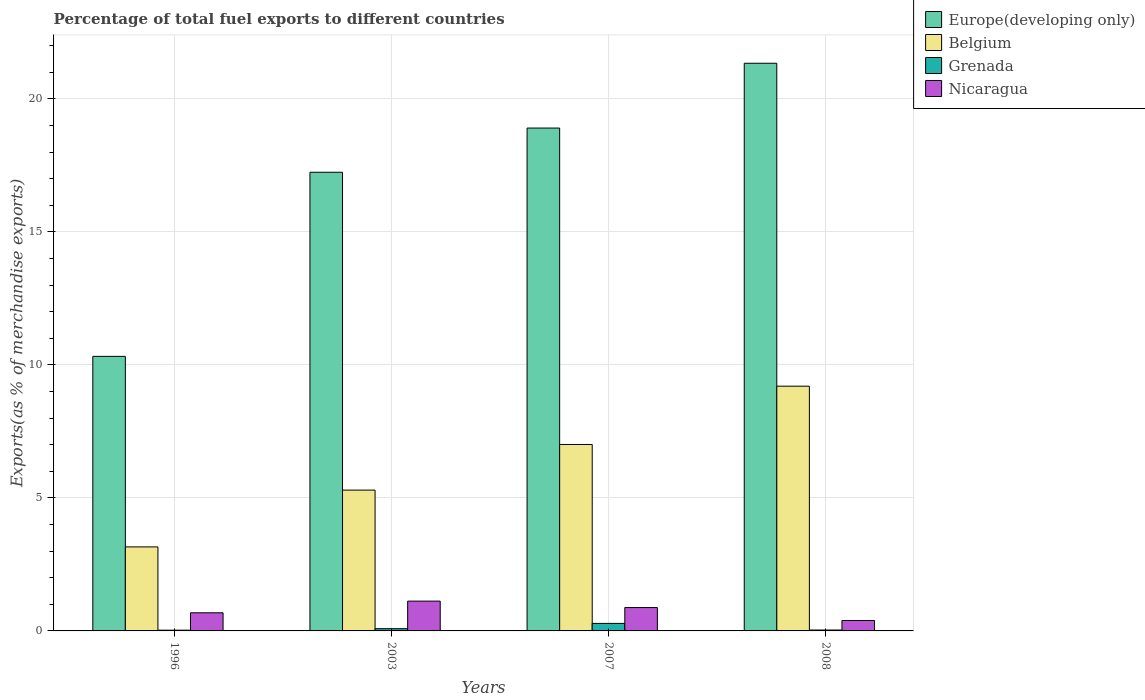Are the number of bars on each tick of the X-axis equal?
Make the answer very short. Yes. How many bars are there on the 1st tick from the right?
Your answer should be compact. 4. In how many cases, is the number of bars for a given year not equal to the number of legend labels?
Make the answer very short. 0. What is the percentage of exports to different countries in Europe(developing only) in 2008?
Your response must be concise. 21.34. Across all years, what is the maximum percentage of exports to different countries in Belgium?
Ensure brevity in your answer.  9.2. Across all years, what is the minimum percentage of exports to different countries in Belgium?
Offer a very short reply. 3.16. What is the total percentage of exports to different countries in Belgium in the graph?
Provide a succinct answer. 24.66. What is the difference between the percentage of exports to different countries in Grenada in 2007 and that in 2008?
Make the answer very short. 0.25. What is the difference between the percentage of exports to different countries in Grenada in 2007 and the percentage of exports to different countries in Nicaragua in 1996?
Give a very brief answer. -0.4. What is the average percentage of exports to different countries in Nicaragua per year?
Offer a very short reply. 0.77. In the year 2003, what is the difference between the percentage of exports to different countries in Belgium and percentage of exports to different countries in Grenada?
Offer a very short reply. 5.21. In how many years, is the percentage of exports to different countries in Europe(developing only) greater than 15 %?
Give a very brief answer. 3. What is the ratio of the percentage of exports to different countries in Europe(developing only) in 1996 to that in 2008?
Ensure brevity in your answer.  0.48. Is the percentage of exports to different countries in Nicaragua in 1996 less than that in 2008?
Ensure brevity in your answer.  No. Is the difference between the percentage of exports to different countries in Belgium in 1996 and 2008 greater than the difference between the percentage of exports to different countries in Grenada in 1996 and 2008?
Ensure brevity in your answer.  No. What is the difference between the highest and the second highest percentage of exports to different countries in Europe(developing only)?
Provide a short and direct response. 2.44. What is the difference between the highest and the lowest percentage of exports to different countries in Grenada?
Ensure brevity in your answer.  0.25. In how many years, is the percentage of exports to different countries in Europe(developing only) greater than the average percentage of exports to different countries in Europe(developing only) taken over all years?
Provide a succinct answer. 3. Is the sum of the percentage of exports to different countries in Belgium in 2003 and 2008 greater than the maximum percentage of exports to different countries in Nicaragua across all years?
Provide a succinct answer. Yes. Is it the case that in every year, the sum of the percentage of exports to different countries in Grenada and percentage of exports to different countries in Nicaragua is greater than the sum of percentage of exports to different countries in Europe(developing only) and percentage of exports to different countries in Belgium?
Ensure brevity in your answer.  Yes. What does the 1st bar from the right in 2007 represents?
Provide a short and direct response. Nicaragua. How many bars are there?
Ensure brevity in your answer.  16. What is the difference between two consecutive major ticks on the Y-axis?
Offer a very short reply. 5. Are the values on the major ticks of Y-axis written in scientific E-notation?
Keep it short and to the point. No. Does the graph contain any zero values?
Your response must be concise. No. Does the graph contain grids?
Provide a succinct answer. Yes. Where does the legend appear in the graph?
Provide a succinct answer. Top right. How are the legend labels stacked?
Your answer should be compact. Vertical. What is the title of the graph?
Provide a succinct answer. Percentage of total fuel exports to different countries. What is the label or title of the Y-axis?
Ensure brevity in your answer.  Exports(as % of merchandise exports). What is the Exports(as % of merchandise exports) in Europe(developing only) in 1996?
Make the answer very short. 10.32. What is the Exports(as % of merchandise exports) in Belgium in 1996?
Keep it short and to the point. 3.16. What is the Exports(as % of merchandise exports) in Grenada in 1996?
Your answer should be very brief. 0.03. What is the Exports(as % of merchandise exports) in Nicaragua in 1996?
Your answer should be very brief. 0.68. What is the Exports(as % of merchandise exports) of Europe(developing only) in 2003?
Provide a succinct answer. 17.24. What is the Exports(as % of merchandise exports) of Belgium in 2003?
Provide a succinct answer. 5.29. What is the Exports(as % of merchandise exports) of Grenada in 2003?
Provide a succinct answer. 0.08. What is the Exports(as % of merchandise exports) in Nicaragua in 2003?
Provide a short and direct response. 1.12. What is the Exports(as % of merchandise exports) of Europe(developing only) in 2007?
Give a very brief answer. 18.9. What is the Exports(as % of merchandise exports) of Belgium in 2007?
Offer a terse response. 7.01. What is the Exports(as % of merchandise exports) of Grenada in 2007?
Make the answer very short. 0.28. What is the Exports(as % of merchandise exports) in Nicaragua in 2007?
Your answer should be compact. 0.88. What is the Exports(as % of merchandise exports) of Europe(developing only) in 2008?
Provide a short and direct response. 21.34. What is the Exports(as % of merchandise exports) in Belgium in 2008?
Your response must be concise. 9.2. What is the Exports(as % of merchandise exports) in Grenada in 2008?
Your response must be concise. 0.03. What is the Exports(as % of merchandise exports) of Nicaragua in 2008?
Your answer should be very brief. 0.39. Across all years, what is the maximum Exports(as % of merchandise exports) in Europe(developing only)?
Give a very brief answer. 21.34. Across all years, what is the maximum Exports(as % of merchandise exports) in Belgium?
Offer a terse response. 9.2. Across all years, what is the maximum Exports(as % of merchandise exports) of Grenada?
Provide a short and direct response. 0.28. Across all years, what is the maximum Exports(as % of merchandise exports) of Nicaragua?
Give a very brief answer. 1.12. Across all years, what is the minimum Exports(as % of merchandise exports) in Europe(developing only)?
Provide a succinct answer. 10.32. Across all years, what is the minimum Exports(as % of merchandise exports) in Belgium?
Offer a terse response. 3.16. Across all years, what is the minimum Exports(as % of merchandise exports) in Grenada?
Ensure brevity in your answer.  0.03. Across all years, what is the minimum Exports(as % of merchandise exports) of Nicaragua?
Provide a short and direct response. 0.39. What is the total Exports(as % of merchandise exports) of Europe(developing only) in the graph?
Ensure brevity in your answer.  67.81. What is the total Exports(as % of merchandise exports) of Belgium in the graph?
Make the answer very short. 24.66. What is the total Exports(as % of merchandise exports) of Grenada in the graph?
Offer a very short reply. 0.43. What is the total Exports(as % of merchandise exports) in Nicaragua in the graph?
Keep it short and to the point. 3.07. What is the difference between the Exports(as % of merchandise exports) of Europe(developing only) in 1996 and that in 2003?
Give a very brief answer. -6.92. What is the difference between the Exports(as % of merchandise exports) in Belgium in 1996 and that in 2003?
Ensure brevity in your answer.  -2.14. What is the difference between the Exports(as % of merchandise exports) in Grenada in 1996 and that in 2003?
Give a very brief answer. -0.06. What is the difference between the Exports(as % of merchandise exports) of Nicaragua in 1996 and that in 2003?
Provide a succinct answer. -0.44. What is the difference between the Exports(as % of merchandise exports) in Europe(developing only) in 1996 and that in 2007?
Your response must be concise. -8.58. What is the difference between the Exports(as % of merchandise exports) of Belgium in 1996 and that in 2007?
Your answer should be compact. -3.85. What is the difference between the Exports(as % of merchandise exports) of Grenada in 1996 and that in 2007?
Offer a terse response. -0.25. What is the difference between the Exports(as % of merchandise exports) in Nicaragua in 1996 and that in 2007?
Provide a succinct answer. -0.2. What is the difference between the Exports(as % of merchandise exports) of Europe(developing only) in 1996 and that in 2008?
Offer a very short reply. -11.02. What is the difference between the Exports(as % of merchandise exports) in Belgium in 1996 and that in 2008?
Make the answer very short. -6.04. What is the difference between the Exports(as % of merchandise exports) of Grenada in 1996 and that in 2008?
Keep it short and to the point. -0.01. What is the difference between the Exports(as % of merchandise exports) in Nicaragua in 1996 and that in 2008?
Your answer should be compact. 0.29. What is the difference between the Exports(as % of merchandise exports) in Europe(developing only) in 2003 and that in 2007?
Ensure brevity in your answer.  -1.66. What is the difference between the Exports(as % of merchandise exports) of Belgium in 2003 and that in 2007?
Offer a terse response. -1.71. What is the difference between the Exports(as % of merchandise exports) of Grenada in 2003 and that in 2007?
Keep it short and to the point. -0.2. What is the difference between the Exports(as % of merchandise exports) of Nicaragua in 2003 and that in 2007?
Your answer should be compact. 0.24. What is the difference between the Exports(as % of merchandise exports) in Europe(developing only) in 2003 and that in 2008?
Your answer should be compact. -4.1. What is the difference between the Exports(as % of merchandise exports) of Belgium in 2003 and that in 2008?
Provide a succinct answer. -3.91. What is the difference between the Exports(as % of merchandise exports) in Grenada in 2003 and that in 2008?
Your response must be concise. 0.05. What is the difference between the Exports(as % of merchandise exports) of Nicaragua in 2003 and that in 2008?
Give a very brief answer. 0.73. What is the difference between the Exports(as % of merchandise exports) in Europe(developing only) in 2007 and that in 2008?
Keep it short and to the point. -2.44. What is the difference between the Exports(as % of merchandise exports) of Belgium in 2007 and that in 2008?
Offer a terse response. -2.19. What is the difference between the Exports(as % of merchandise exports) of Grenada in 2007 and that in 2008?
Provide a succinct answer. 0.25. What is the difference between the Exports(as % of merchandise exports) of Nicaragua in 2007 and that in 2008?
Provide a succinct answer. 0.49. What is the difference between the Exports(as % of merchandise exports) in Europe(developing only) in 1996 and the Exports(as % of merchandise exports) in Belgium in 2003?
Your answer should be very brief. 5.03. What is the difference between the Exports(as % of merchandise exports) of Europe(developing only) in 1996 and the Exports(as % of merchandise exports) of Grenada in 2003?
Offer a very short reply. 10.24. What is the difference between the Exports(as % of merchandise exports) of Europe(developing only) in 1996 and the Exports(as % of merchandise exports) of Nicaragua in 2003?
Keep it short and to the point. 9.2. What is the difference between the Exports(as % of merchandise exports) in Belgium in 1996 and the Exports(as % of merchandise exports) in Grenada in 2003?
Give a very brief answer. 3.07. What is the difference between the Exports(as % of merchandise exports) in Belgium in 1996 and the Exports(as % of merchandise exports) in Nicaragua in 2003?
Offer a terse response. 2.04. What is the difference between the Exports(as % of merchandise exports) of Grenada in 1996 and the Exports(as % of merchandise exports) of Nicaragua in 2003?
Provide a short and direct response. -1.09. What is the difference between the Exports(as % of merchandise exports) in Europe(developing only) in 1996 and the Exports(as % of merchandise exports) in Belgium in 2007?
Your answer should be compact. 3.31. What is the difference between the Exports(as % of merchandise exports) of Europe(developing only) in 1996 and the Exports(as % of merchandise exports) of Grenada in 2007?
Offer a terse response. 10.04. What is the difference between the Exports(as % of merchandise exports) of Europe(developing only) in 1996 and the Exports(as % of merchandise exports) of Nicaragua in 2007?
Give a very brief answer. 9.44. What is the difference between the Exports(as % of merchandise exports) of Belgium in 1996 and the Exports(as % of merchandise exports) of Grenada in 2007?
Your answer should be very brief. 2.88. What is the difference between the Exports(as % of merchandise exports) of Belgium in 1996 and the Exports(as % of merchandise exports) of Nicaragua in 2007?
Make the answer very short. 2.28. What is the difference between the Exports(as % of merchandise exports) of Grenada in 1996 and the Exports(as % of merchandise exports) of Nicaragua in 2007?
Provide a succinct answer. -0.85. What is the difference between the Exports(as % of merchandise exports) in Europe(developing only) in 1996 and the Exports(as % of merchandise exports) in Belgium in 2008?
Provide a short and direct response. 1.12. What is the difference between the Exports(as % of merchandise exports) in Europe(developing only) in 1996 and the Exports(as % of merchandise exports) in Grenada in 2008?
Make the answer very short. 10.29. What is the difference between the Exports(as % of merchandise exports) in Europe(developing only) in 1996 and the Exports(as % of merchandise exports) in Nicaragua in 2008?
Keep it short and to the point. 9.93. What is the difference between the Exports(as % of merchandise exports) in Belgium in 1996 and the Exports(as % of merchandise exports) in Grenada in 2008?
Your answer should be very brief. 3.12. What is the difference between the Exports(as % of merchandise exports) in Belgium in 1996 and the Exports(as % of merchandise exports) in Nicaragua in 2008?
Your answer should be compact. 2.77. What is the difference between the Exports(as % of merchandise exports) in Grenada in 1996 and the Exports(as % of merchandise exports) in Nicaragua in 2008?
Offer a very short reply. -0.36. What is the difference between the Exports(as % of merchandise exports) in Europe(developing only) in 2003 and the Exports(as % of merchandise exports) in Belgium in 2007?
Offer a terse response. 10.23. What is the difference between the Exports(as % of merchandise exports) of Europe(developing only) in 2003 and the Exports(as % of merchandise exports) of Grenada in 2007?
Offer a terse response. 16.96. What is the difference between the Exports(as % of merchandise exports) in Europe(developing only) in 2003 and the Exports(as % of merchandise exports) in Nicaragua in 2007?
Your answer should be very brief. 16.36. What is the difference between the Exports(as % of merchandise exports) of Belgium in 2003 and the Exports(as % of merchandise exports) of Grenada in 2007?
Give a very brief answer. 5.01. What is the difference between the Exports(as % of merchandise exports) in Belgium in 2003 and the Exports(as % of merchandise exports) in Nicaragua in 2007?
Give a very brief answer. 4.42. What is the difference between the Exports(as % of merchandise exports) of Grenada in 2003 and the Exports(as % of merchandise exports) of Nicaragua in 2007?
Offer a terse response. -0.79. What is the difference between the Exports(as % of merchandise exports) of Europe(developing only) in 2003 and the Exports(as % of merchandise exports) of Belgium in 2008?
Provide a succinct answer. 8.04. What is the difference between the Exports(as % of merchandise exports) in Europe(developing only) in 2003 and the Exports(as % of merchandise exports) in Grenada in 2008?
Your answer should be compact. 17.21. What is the difference between the Exports(as % of merchandise exports) of Europe(developing only) in 2003 and the Exports(as % of merchandise exports) of Nicaragua in 2008?
Provide a short and direct response. 16.85. What is the difference between the Exports(as % of merchandise exports) in Belgium in 2003 and the Exports(as % of merchandise exports) in Grenada in 2008?
Your answer should be very brief. 5.26. What is the difference between the Exports(as % of merchandise exports) of Belgium in 2003 and the Exports(as % of merchandise exports) of Nicaragua in 2008?
Your response must be concise. 4.9. What is the difference between the Exports(as % of merchandise exports) in Grenada in 2003 and the Exports(as % of merchandise exports) in Nicaragua in 2008?
Your answer should be compact. -0.31. What is the difference between the Exports(as % of merchandise exports) of Europe(developing only) in 2007 and the Exports(as % of merchandise exports) of Belgium in 2008?
Your answer should be very brief. 9.7. What is the difference between the Exports(as % of merchandise exports) in Europe(developing only) in 2007 and the Exports(as % of merchandise exports) in Grenada in 2008?
Ensure brevity in your answer.  18.87. What is the difference between the Exports(as % of merchandise exports) in Europe(developing only) in 2007 and the Exports(as % of merchandise exports) in Nicaragua in 2008?
Your answer should be compact. 18.51. What is the difference between the Exports(as % of merchandise exports) of Belgium in 2007 and the Exports(as % of merchandise exports) of Grenada in 2008?
Your response must be concise. 6.98. What is the difference between the Exports(as % of merchandise exports) in Belgium in 2007 and the Exports(as % of merchandise exports) in Nicaragua in 2008?
Make the answer very short. 6.62. What is the difference between the Exports(as % of merchandise exports) of Grenada in 2007 and the Exports(as % of merchandise exports) of Nicaragua in 2008?
Offer a terse response. -0.11. What is the average Exports(as % of merchandise exports) of Europe(developing only) per year?
Ensure brevity in your answer.  16.95. What is the average Exports(as % of merchandise exports) of Belgium per year?
Your response must be concise. 6.17. What is the average Exports(as % of merchandise exports) of Grenada per year?
Your answer should be very brief. 0.11. What is the average Exports(as % of merchandise exports) in Nicaragua per year?
Offer a terse response. 0.77. In the year 1996, what is the difference between the Exports(as % of merchandise exports) in Europe(developing only) and Exports(as % of merchandise exports) in Belgium?
Give a very brief answer. 7.16. In the year 1996, what is the difference between the Exports(as % of merchandise exports) in Europe(developing only) and Exports(as % of merchandise exports) in Grenada?
Offer a terse response. 10.29. In the year 1996, what is the difference between the Exports(as % of merchandise exports) in Europe(developing only) and Exports(as % of merchandise exports) in Nicaragua?
Make the answer very short. 9.64. In the year 1996, what is the difference between the Exports(as % of merchandise exports) in Belgium and Exports(as % of merchandise exports) in Grenada?
Your answer should be very brief. 3.13. In the year 1996, what is the difference between the Exports(as % of merchandise exports) of Belgium and Exports(as % of merchandise exports) of Nicaragua?
Your response must be concise. 2.48. In the year 1996, what is the difference between the Exports(as % of merchandise exports) in Grenada and Exports(as % of merchandise exports) in Nicaragua?
Provide a short and direct response. -0.65. In the year 2003, what is the difference between the Exports(as % of merchandise exports) in Europe(developing only) and Exports(as % of merchandise exports) in Belgium?
Make the answer very short. 11.95. In the year 2003, what is the difference between the Exports(as % of merchandise exports) in Europe(developing only) and Exports(as % of merchandise exports) in Grenada?
Give a very brief answer. 17.16. In the year 2003, what is the difference between the Exports(as % of merchandise exports) in Europe(developing only) and Exports(as % of merchandise exports) in Nicaragua?
Provide a succinct answer. 16.12. In the year 2003, what is the difference between the Exports(as % of merchandise exports) of Belgium and Exports(as % of merchandise exports) of Grenada?
Give a very brief answer. 5.21. In the year 2003, what is the difference between the Exports(as % of merchandise exports) in Belgium and Exports(as % of merchandise exports) in Nicaragua?
Offer a terse response. 4.17. In the year 2003, what is the difference between the Exports(as % of merchandise exports) in Grenada and Exports(as % of merchandise exports) in Nicaragua?
Offer a very short reply. -1.04. In the year 2007, what is the difference between the Exports(as % of merchandise exports) of Europe(developing only) and Exports(as % of merchandise exports) of Belgium?
Your answer should be very brief. 11.9. In the year 2007, what is the difference between the Exports(as % of merchandise exports) of Europe(developing only) and Exports(as % of merchandise exports) of Grenada?
Your answer should be very brief. 18.62. In the year 2007, what is the difference between the Exports(as % of merchandise exports) in Europe(developing only) and Exports(as % of merchandise exports) in Nicaragua?
Give a very brief answer. 18.03. In the year 2007, what is the difference between the Exports(as % of merchandise exports) of Belgium and Exports(as % of merchandise exports) of Grenada?
Your response must be concise. 6.73. In the year 2007, what is the difference between the Exports(as % of merchandise exports) in Belgium and Exports(as % of merchandise exports) in Nicaragua?
Provide a short and direct response. 6.13. In the year 2007, what is the difference between the Exports(as % of merchandise exports) of Grenada and Exports(as % of merchandise exports) of Nicaragua?
Your response must be concise. -0.6. In the year 2008, what is the difference between the Exports(as % of merchandise exports) in Europe(developing only) and Exports(as % of merchandise exports) in Belgium?
Ensure brevity in your answer.  12.14. In the year 2008, what is the difference between the Exports(as % of merchandise exports) of Europe(developing only) and Exports(as % of merchandise exports) of Grenada?
Provide a succinct answer. 21.31. In the year 2008, what is the difference between the Exports(as % of merchandise exports) of Europe(developing only) and Exports(as % of merchandise exports) of Nicaragua?
Offer a terse response. 20.95. In the year 2008, what is the difference between the Exports(as % of merchandise exports) in Belgium and Exports(as % of merchandise exports) in Grenada?
Your response must be concise. 9.17. In the year 2008, what is the difference between the Exports(as % of merchandise exports) in Belgium and Exports(as % of merchandise exports) in Nicaragua?
Your answer should be compact. 8.81. In the year 2008, what is the difference between the Exports(as % of merchandise exports) of Grenada and Exports(as % of merchandise exports) of Nicaragua?
Provide a succinct answer. -0.36. What is the ratio of the Exports(as % of merchandise exports) in Europe(developing only) in 1996 to that in 2003?
Give a very brief answer. 0.6. What is the ratio of the Exports(as % of merchandise exports) of Belgium in 1996 to that in 2003?
Offer a very short reply. 0.6. What is the ratio of the Exports(as % of merchandise exports) in Grenada in 1996 to that in 2003?
Keep it short and to the point. 0.33. What is the ratio of the Exports(as % of merchandise exports) of Nicaragua in 1996 to that in 2003?
Your answer should be very brief. 0.61. What is the ratio of the Exports(as % of merchandise exports) in Europe(developing only) in 1996 to that in 2007?
Ensure brevity in your answer.  0.55. What is the ratio of the Exports(as % of merchandise exports) in Belgium in 1996 to that in 2007?
Offer a very short reply. 0.45. What is the ratio of the Exports(as % of merchandise exports) of Grenada in 1996 to that in 2007?
Ensure brevity in your answer.  0.1. What is the ratio of the Exports(as % of merchandise exports) of Nicaragua in 1996 to that in 2007?
Your response must be concise. 0.78. What is the ratio of the Exports(as % of merchandise exports) of Europe(developing only) in 1996 to that in 2008?
Provide a short and direct response. 0.48. What is the ratio of the Exports(as % of merchandise exports) in Belgium in 1996 to that in 2008?
Keep it short and to the point. 0.34. What is the ratio of the Exports(as % of merchandise exports) of Grenada in 1996 to that in 2008?
Keep it short and to the point. 0.82. What is the ratio of the Exports(as % of merchandise exports) of Nicaragua in 1996 to that in 2008?
Provide a short and direct response. 1.74. What is the ratio of the Exports(as % of merchandise exports) in Europe(developing only) in 2003 to that in 2007?
Make the answer very short. 0.91. What is the ratio of the Exports(as % of merchandise exports) in Belgium in 2003 to that in 2007?
Keep it short and to the point. 0.76. What is the ratio of the Exports(as % of merchandise exports) of Grenada in 2003 to that in 2007?
Keep it short and to the point. 0.3. What is the ratio of the Exports(as % of merchandise exports) of Nicaragua in 2003 to that in 2007?
Provide a succinct answer. 1.28. What is the ratio of the Exports(as % of merchandise exports) in Europe(developing only) in 2003 to that in 2008?
Your answer should be compact. 0.81. What is the ratio of the Exports(as % of merchandise exports) of Belgium in 2003 to that in 2008?
Provide a succinct answer. 0.58. What is the ratio of the Exports(as % of merchandise exports) of Grenada in 2003 to that in 2008?
Offer a very short reply. 2.48. What is the ratio of the Exports(as % of merchandise exports) of Nicaragua in 2003 to that in 2008?
Offer a terse response. 2.86. What is the ratio of the Exports(as % of merchandise exports) of Europe(developing only) in 2007 to that in 2008?
Your response must be concise. 0.89. What is the ratio of the Exports(as % of merchandise exports) in Belgium in 2007 to that in 2008?
Your answer should be very brief. 0.76. What is the ratio of the Exports(as % of merchandise exports) of Grenada in 2007 to that in 2008?
Provide a succinct answer. 8.36. What is the ratio of the Exports(as % of merchandise exports) in Nicaragua in 2007 to that in 2008?
Provide a succinct answer. 2.24. What is the difference between the highest and the second highest Exports(as % of merchandise exports) in Europe(developing only)?
Provide a succinct answer. 2.44. What is the difference between the highest and the second highest Exports(as % of merchandise exports) in Belgium?
Offer a very short reply. 2.19. What is the difference between the highest and the second highest Exports(as % of merchandise exports) in Grenada?
Your response must be concise. 0.2. What is the difference between the highest and the second highest Exports(as % of merchandise exports) of Nicaragua?
Make the answer very short. 0.24. What is the difference between the highest and the lowest Exports(as % of merchandise exports) of Europe(developing only)?
Provide a short and direct response. 11.02. What is the difference between the highest and the lowest Exports(as % of merchandise exports) of Belgium?
Provide a succinct answer. 6.04. What is the difference between the highest and the lowest Exports(as % of merchandise exports) in Grenada?
Keep it short and to the point. 0.25. What is the difference between the highest and the lowest Exports(as % of merchandise exports) in Nicaragua?
Provide a short and direct response. 0.73. 